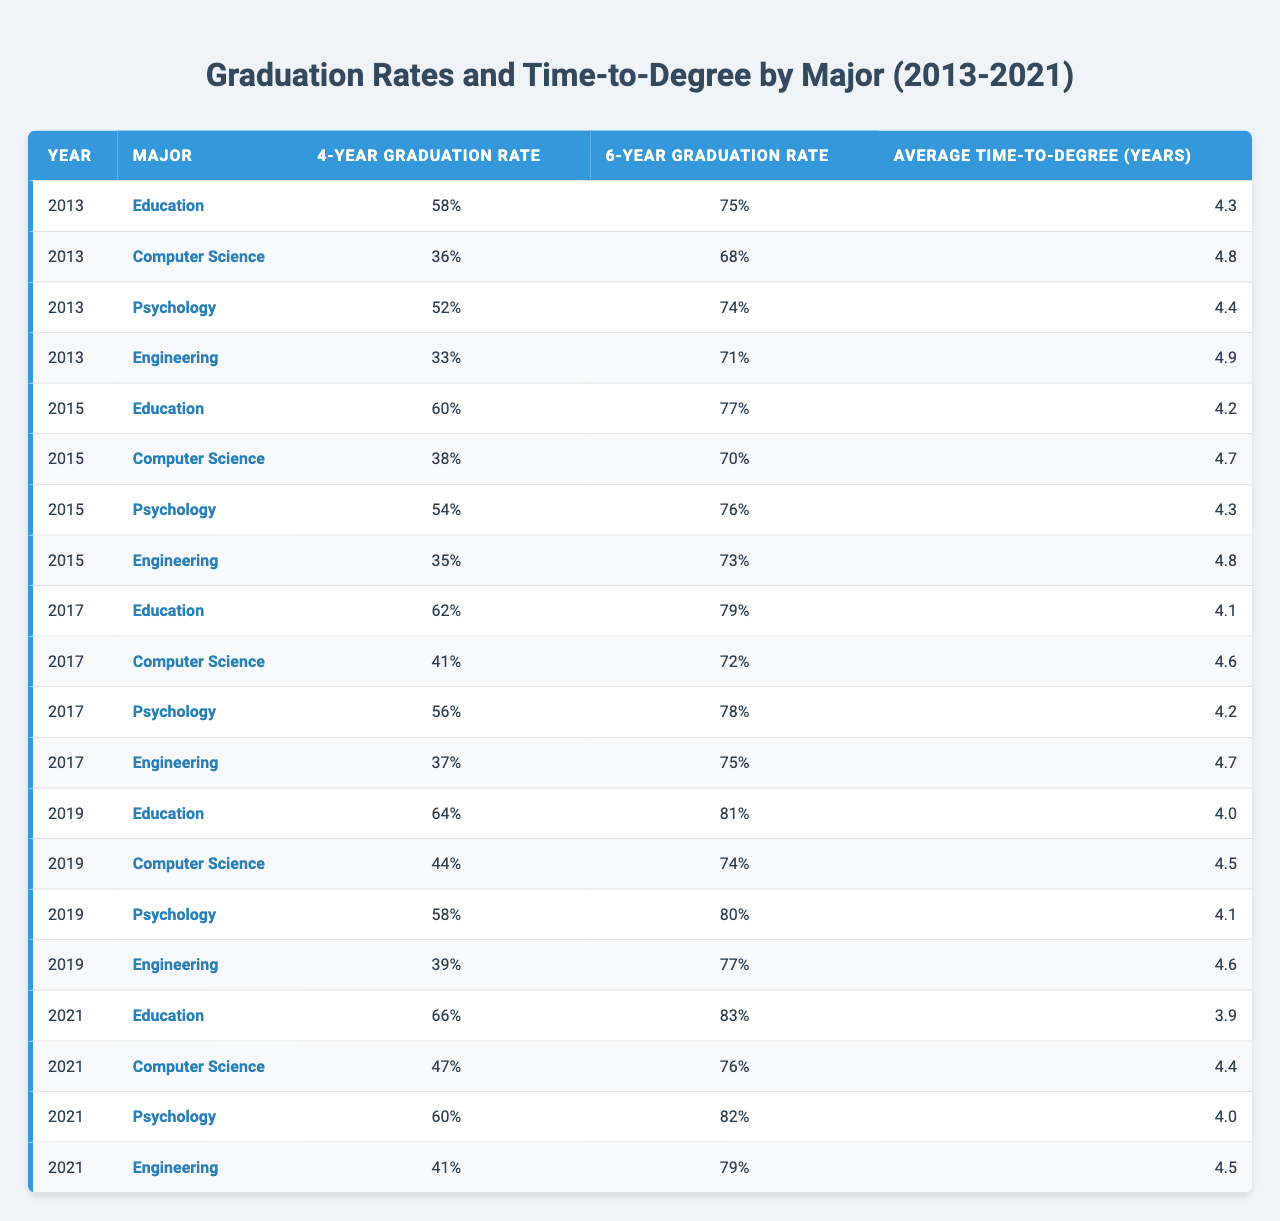What was the 4-year graduation rate for Computer Science in 2019? According to the table, the 4-year graduation rate for Computer Science in 2019 is explicitly stated as 44%.
Answer: 44% Which major had the highest 6-year graduation rate in 2021? The table shows that in 2021, Education had the highest 6-year graduation rate at 83%.
Answer: Education What is the difference between the 4-year graduation rates of Engineering in 2013 and 2021? The 4-year graduation rate for Engineering in 2013 is 33% and in 2021 is 41%. The difference is calculated as 41% - 33% = 8%.
Answer: 8% In which year did Psychology have its lowest 4-year graduation rate? By examining the table, Psychology had its lowest 4-year graduation rate of 52% in 2013.
Answer: 2013 What is the average time-to-degree for Education across all the years presented? To find the average time-to-degree for Education, sum the time-to-degrees: 4.3 + 4.2 + 4.1 + 4.0 + 3.9 = 20.5. Then divide by 5 (the number of years) to get 20.5 / 5 = 4.1 years.
Answer: 4.1 years Did the 4-year graduation rate for Engineering improve from 2013 to 2021? Yes, the 4-year graduation rate for Engineering increased from 33% in 2013 to 41% in 2021, indicating improvement.
Answer: Yes Which major consistently had the lowest 4-year graduation rate over the years? Reviewing the table, Engineering consistently had the lowest 4-year graduation rates in all years compared to other majors, starting from 33% in 2013 to 41% in 2021.
Answer: Engineering What is the highest average time-to-degree across any major in the table? Upon reviewing the data, Engineering has the highest average time-to-degree of 4.9 years in 2013.
Answer: 4.9 years How did the 6-year graduation rate for Computer Science change from 2013 to 2021? In the table, Computer Science had a 6-year graduation rate of 68% in 2013 and a rate of 76% in 2021, showing an increase of 8%.
Answer: Increased by 8% Was there any year when Education had a graduation rate below 60%? By viewing the table, Education never had a 4-year or 6-year graduation rate below 60% from 2013 to 2021.
Answer: No 